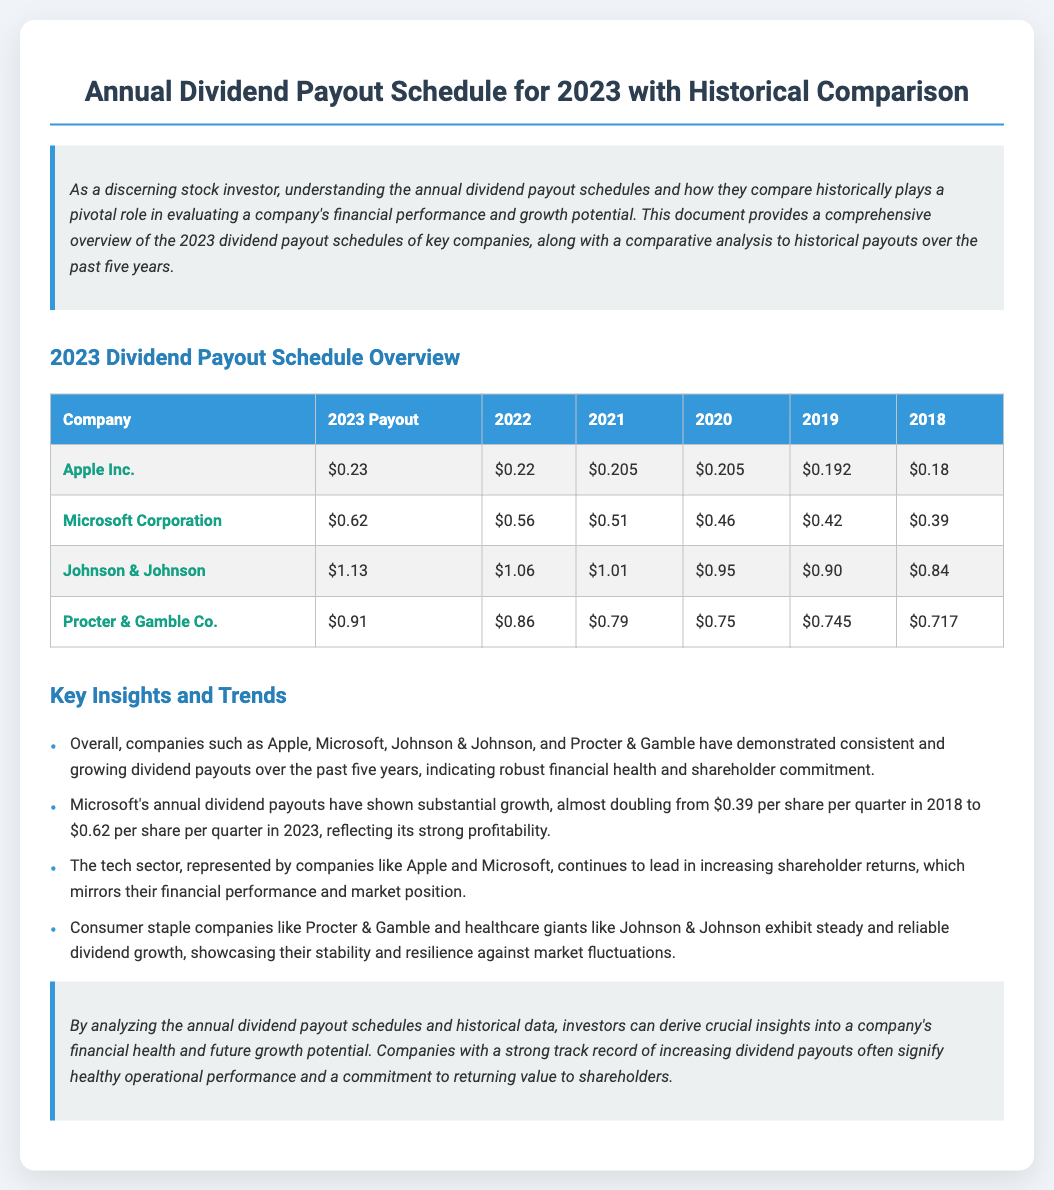what is the 2023 dividend payout for Apple Inc.? The 2023 dividend payout for Apple Inc. is listed in the table of the document.
Answer: $0.23 what was the 2022 payout for Microsoft Corporation? The 2022 payout for Microsoft Corporation can be found in the comparative section of the table.
Answer: $0.56 which company had the highest payout in 2023? Analyzing the table, the company with the highest payout in 2023 can be identified.
Answer: Johnson & Johnson how much did Procter & Gamble Co. pay in 2020? The payout for Procter & Gamble Co. in 2020 can be retrieved from the historical data section of the table.
Answer: $0.75 what is the trend observed for Microsoft’s annual dividends? The document discusses the trend in the "Key Insights and Trends" section.
Answer: Substantial growth which sector is noted for leading in increasing shareholder returns? The text highlights specific sectors that exhibit trends in the document.
Answer: Tech sector how many years of data are compared in the table? The document specifies the range of years for the comparison in the table.
Answer: Six years what is the theme of the conclusion? The conclusion summarizes the key insights derived from the analysis presented in the document.
Answer: Financial health what recurring pattern is seen with dividends from companies like Johnson & Johnson? The document refers to consistent behaviors of certain companies with regard to their dividend payouts.
Answer: Steady growth 